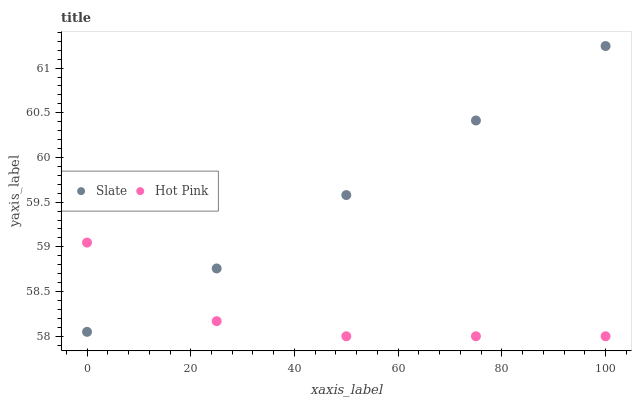Does Hot Pink have the minimum area under the curve?
Answer yes or no. Yes. Does Slate have the maximum area under the curve?
Answer yes or no. Yes. Does Hot Pink have the maximum area under the curve?
Answer yes or no. No. Is Slate the smoothest?
Answer yes or no. Yes. Is Hot Pink the roughest?
Answer yes or no. Yes. Is Hot Pink the smoothest?
Answer yes or no. No. Does Hot Pink have the lowest value?
Answer yes or no. Yes. Does Slate have the highest value?
Answer yes or no. Yes. Does Hot Pink have the highest value?
Answer yes or no. No. Does Slate intersect Hot Pink?
Answer yes or no. Yes. Is Slate less than Hot Pink?
Answer yes or no. No. Is Slate greater than Hot Pink?
Answer yes or no. No. 